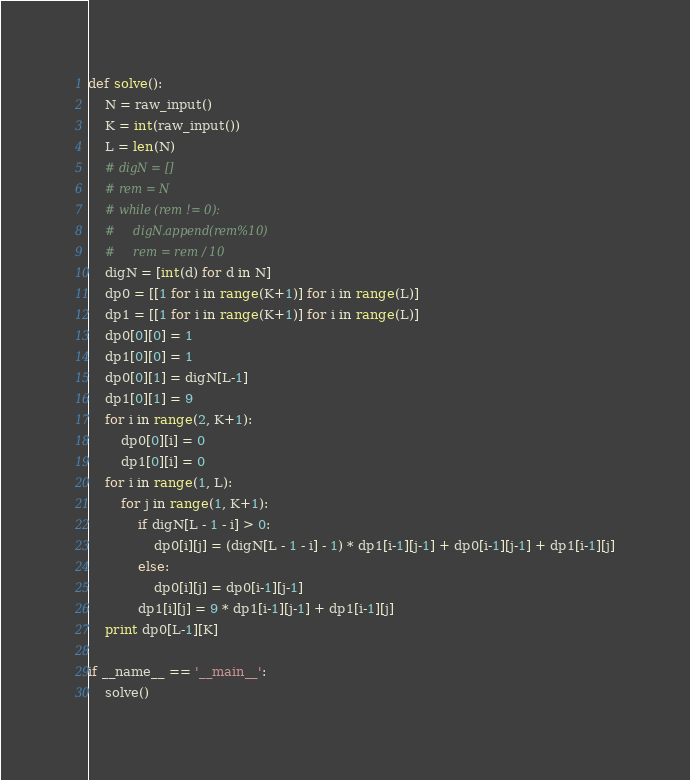Convert code to text. <code><loc_0><loc_0><loc_500><loc_500><_Python_>def solve():
    N = raw_input()
    K = int(raw_input())
    L = len(N)
    # digN = []
    # rem = N
    # while (rem != 0):
    #     digN.append(rem%10)
    #     rem = rem / 10
    digN = [int(d) for d in N]
    dp0 = [[1 for i in range(K+1)] for i in range(L)]
    dp1 = [[1 for i in range(K+1)] for i in range(L)]
    dp0[0][0] = 1
    dp1[0][0] = 1
    dp0[0][1] = digN[L-1]
    dp1[0][1] = 9
    for i in range(2, K+1):
        dp0[0][i] = 0
        dp1[0][i] = 0
    for i in range(1, L):
        for j in range(1, K+1):
            if digN[L - 1 - i] > 0:
                dp0[i][j] = (digN[L - 1 - i] - 1) * dp1[i-1][j-1] + dp0[i-1][j-1] + dp1[i-1][j]
            else:
                dp0[i][j] = dp0[i-1][j-1]
            dp1[i][j] = 9 * dp1[i-1][j-1] + dp1[i-1][j]
    print dp0[L-1][K]

if __name__ == '__main__':
    solve()
</code> 